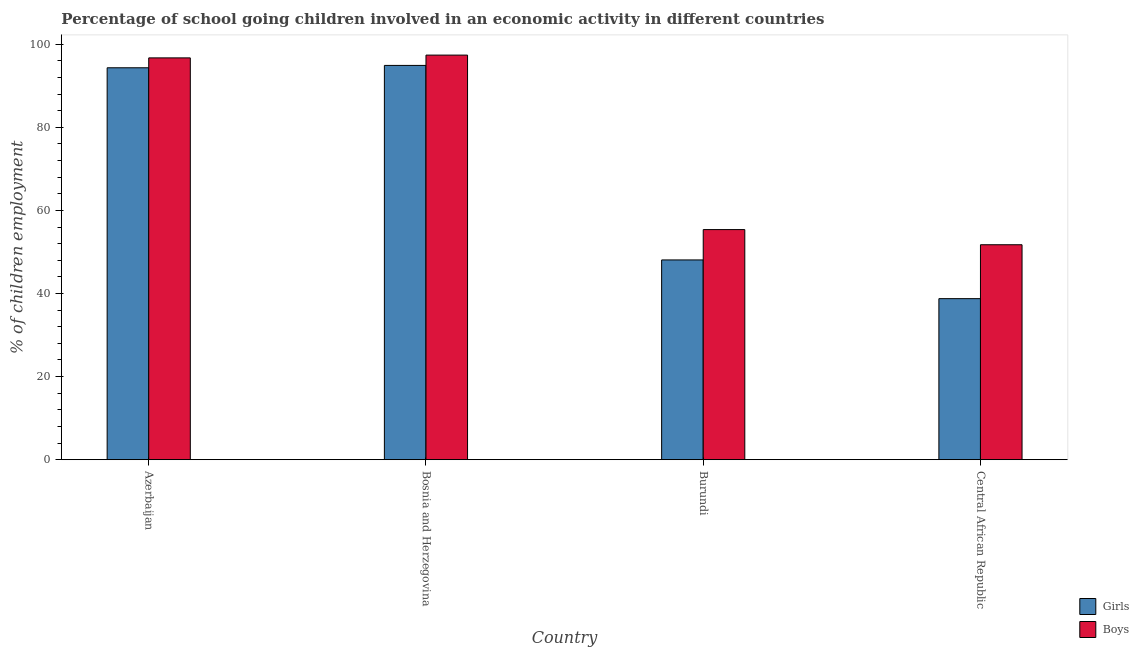How many different coloured bars are there?
Offer a very short reply. 2. How many groups of bars are there?
Provide a short and direct response. 4. Are the number of bars on each tick of the X-axis equal?
Offer a terse response. Yes. What is the label of the 4th group of bars from the left?
Provide a succinct answer. Central African Republic. In how many cases, is the number of bars for a given country not equal to the number of legend labels?
Provide a short and direct response. 0. What is the percentage of school going girls in Azerbaijan?
Offer a terse response. 94.32. Across all countries, what is the maximum percentage of school going girls?
Your answer should be very brief. 94.89. Across all countries, what is the minimum percentage of school going boys?
Make the answer very short. 51.73. In which country was the percentage of school going boys maximum?
Offer a terse response. Bosnia and Herzegovina. In which country was the percentage of school going boys minimum?
Your answer should be compact. Central African Republic. What is the total percentage of school going girls in the graph?
Keep it short and to the point. 276.04. What is the difference between the percentage of school going girls in Bosnia and Herzegovina and that in Central African Republic?
Your answer should be compact. 56.13. What is the difference between the percentage of school going boys in Burundi and the percentage of school going girls in Central African Republic?
Your answer should be very brief. 16.62. What is the average percentage of school going girls per country?
Ensure brevity in your answer.  69.01. What is the difference between the percentage of school going boys and percentage of school going girls in Central African Republic?
Ensure brevity in your answer.  12.97. In how many countries, is the percentage of school going girls greater than 80 %?
Ensure brevity in your answer.  2. What is the ratio of the percentage of school going girls in Azerbaijan to that in Bosnia and Herzegovina?
Your answer should be very brief. 0.99. What is the difference between the highest and the second highest percentage of school going girls?
Your response must be concise. 0.57. What is the difference between the highest and the lowest percentage of school going boys?
Provide a short and direct response. 45.64. What does the 1st bar from the left in Central African Republic represents?
Your answer should be very brief. Girls. What does the 2nd bar from the right in Burundi represents?
Keep it short and to the point. Girls. How many bars are there?
Your answer should be very brief. 8. How many countries are there in the graph?
Your answer should be very brief. 4. Are the values on the major ticks of Y-axis written in scientific E-notation?
Keep it short and to the point. No. Does the graph contain any zero values?
Give a very brief answer. No. Where does the legend appear in the graph?
Make the answer very short. Bottom right. How many legend labels are there?
Your answer should be compact. 2. How are the legend labels stacked?
Make the answer very short. Vertical. What is the title of the graph?
Make the answer very short. Percentage of school going children involved in an economic activity in different countries. Does "Female labor force" appear as one of the legend labels in the graph?
Offer a terse response. No. What is the label or title of the X-axis?
Your answer should be very brief. Country. What is the label or title of the Y-axis?
Keep it short and to the point. % of children employment. What is the % of children employment in Girls in Azerbaijan?
Your answer should be compact. 94.32. What is the % of children employment of Boys in Azerbaijan?
Provide a succinct answer. 96.7. What is the % of children employment in Girls in Bosnia and Herzegovina?
Provide a succinct answer. 94.89. What is the % of children employment in Boys in Bosnia and Herzegovina?
Your response must be concise. 97.37. What is the % of children employment of Girls in Burundi?
Provide a succinct answer. 48.07. What is the % of children employment of Boys in Burundi?
Ensure brevity in your answer.  55.38. What is the % of children employment of Girls in Central African Republic?
Provide a short and direct response. 38.76. What is the % of children employment of Boys in Central African Republic?
Your response must be concise. 51.73. Across all countries, what is the maximum % of children employment of Girls?
Provide a short and direct response. 94.89. Across all countries, what is the maximum % of children employment in Boys?
Your response must be concise. 97.37. Across all countries, what is the minimum % of children employment of Girls?
Your answer should be very brief. 38.76. Across all countries, what is the minimum % of children employment in Boys?
Offer a terse response. 51.73. What is the total % of children employment in Girls in the graph?
Provide a succinct answer. 276.04. What is the total % of children employment of Boys in the graph?
Your answer should be very brief. 301.18. What is the difference between the % of children employment in Girls in Azerbaijan and that in Bosnia and Herzegovina?
Provide a short and direct response. -0.57. What is the difference between the % of children employment in Boys in Azerbaijan and that in Bosnia and Herzegovina?
Your answer should be very brief. -0.67. What is the difference between the % of children employment in Girls in Azerbaijan and that in Burundi?
Make the answer very short. 46.24. What is the difference between the % of children employment in Boys in Azerbaijan and that in Burundi?
Provide a succinct answer. 41.32. What is the difference between the % of children employment of Girls in Azerbaijan and that in Central African Republic?
Ensure brevity in your answer.  55.56. What is the difference between the % of children employment of Boys in Azerbaijan and that in Central African Republic?
Your answer should be compact. 44.97. What is the difference between the % of children employment in Girls in Bosnia and Herzegovina and that in Burundi?
Offer a very short reply. 46.81. What is the difference between the % of children employment of Boys in Bosnia and Herzegovina and that in Burundi?
Offer a very short reply. 41.99. What is the difference between the % of children employment of Girls in Bosnia and Herzegovina and that in Central African Republic?
Give a very brief answer. 56.13. What is the difference between the % of children employment of Boys in Bosnia and Herzegovina and that in Central African Republic?
Your answer should be compact. 45.64. What is the difference between the % of children employment in Girls in Burundi and that in Central African Republic?
Provide a short and direct response. 9.32. What is the difference between the % of children employment of Boys in Burundi and that in Central African Republic?
Keep it short and to the point. 3.65. What is the difference between the % of children employment of Girls in Azerbaijan and the % of children employment of Boys in Bosnia and Herzegovina?
Offer a very short reply. -3.05. What is the difference between the % of children employment of Girls in Azerbaijan and the % of children employment of Boys in Burundi?
Offer a very short reply. 38.94. What is the difference between the % of children employment in Girls in Azerbaijan and the % of children employment in Boys in Central African Republic?
Your answer should be very brief. 42.59. What is the difference between the % of children employment in Girls in Bosnia and Herzegovina and the % of children employment in Boys in Burundi?
Your answer should be compact. 39.51. What is the difference between the % of children employment in Girls in Bosnia and Herzegovina and the % of children employment in Boys in Central African Republic?
Your response must be concise. 43.16. What is the difference between the % of children employment in Girls in Burundi and the % of children employment in Boys in Central African Republic?
Provide a short and direct response. -3.65. What is the average % of children employment in Girls per country?
Make the answer very short. 69.01. What is the average % of children employment in Boys per country?
Offer a very short reply. 75.29. What is the difference between the % of children employment of Girls and % of children employment of Boys in Azerbaijan?
Give a very brief answer. -2.38. What is the difference between the % of children employment in Girls and % of children employment in Boys in Bosnia and Herzegovina?
Your answer should be very brief. -2.48. What is the difference between the % of children employment in Girls and % of children employment in Boys in Burundi?
Your answer should be very brief. -7.3. What is the difference between the % of children employment of Girls and % of children employment of Boys in Central African Republic?
Offer a terse response. -12.97. What is the ratio of the % of children employment of Girls in Azerbaijan to that in Burundi?
Provide a short and direct response. 1.96. What is the ratio of the % of children employment of Boys in Azerbaijan to that in Burundi?
Ensure brevity in your answer.  1.75. What is the ratio of the % of children employment of Girls in Azerbaijan to that in Central African Republic?
Your response must be concise. 2.43. What is the ratio of the % of children employment in Boys in Azerbaijan to that in Central African Republic?
Provide a succinct answer. 1.87. What is the ratio of the % of children employment of Girls in Bosnia and Herzegovina to that in Burundi?
Give a very brief answer. 1.97. What is the ratio of the % of children employment of Boys in Bosnia and Herzegovina to that in Burundi?
Your response must be concise. 1.76. What is the ratio of the % of children employment of Girls in Bosnia and Herzegovina to that in Central African Republic?
Offer a terse response. 2.45. What is the ratio of the % of children employment in Boys in Bosnia and Herzegovina to that in Central African Republic?
Your answer should be very brief. 1.88. What is the ratio of the % of children employment of Girls in Burundi to that in Central African Republic?
Offer a very short reply. 1.24. What is the ratio of the % of children employment of Boys in Burundi to that in Central African Republic?
Keep it short and to the point. 1.07. What is the difference between the highest and the second highest % of children employment in Girls?
Offer a very short reply. 0.57. What is the difference between the highest and the second highest % of children employment of Boys?
Keep it short and to the point. 0.67. What is the difference between the highest and the lowest % of children employment of Girls?
Your response must be concise. 56.13. What is the difference between the highest and the lowest % of children employment in Boys?
Your answer should be compact. 45.64. 